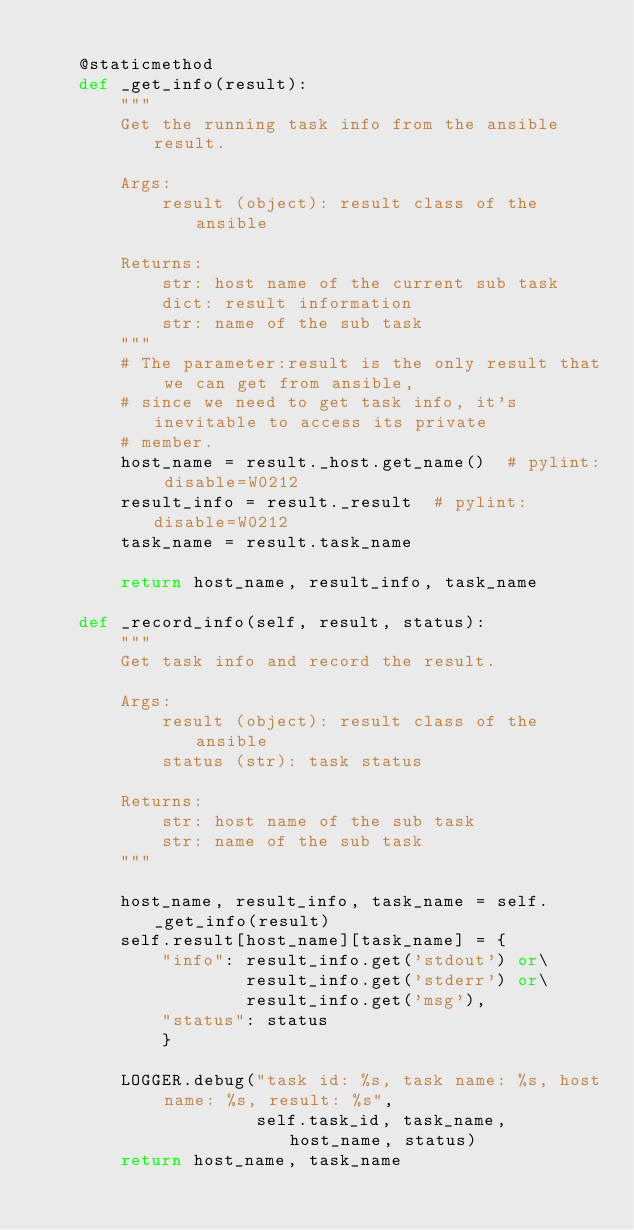Convert code to text. <code><loc_0><loc_0><loc_500><loc_500><_Python_>
    @staticmethod
    def _get_info(result):
        """
        Get the running task info from the ansible result.

        Args:
            result (object): result class of the ansible

        Returns:
            str: host name of the current sub task
            dict: result information
            str: name of the sub task
        """
        # The parameter:result is the only result that we can get from ansible,
        # since we need to get task info, it's inevitable to access its private
        # member.
        host_name = result._host.get_name()  # pylint: disable=W0212
        result_info = result._result  # pylint: disable=W0212
        task_name = result.task_name

        return host_name, result_info, task_name

    def _record_info(self, result, status):
        """
        Get task info and record the result.

        Args:
            result (object): result class of the ansible
            status (str): task status

        Returns:
            str: host name of the sub task
            str: name of the sub task
        """

        host_name, result_info, task_name = self._get_info(result)
        self.result[host_name][task_name] = {
            "info": result_info.get('stdout') or\
                    result_info.get('stderr') or\
                    result_info.get('msg'),
            "status": status
            }

        LOGGER.debug("task id: %s, task name: %s, host name: %s, result: %s",
                     self.task_id, task_name, host_name, status)
        return host_name, task_name
</code> 